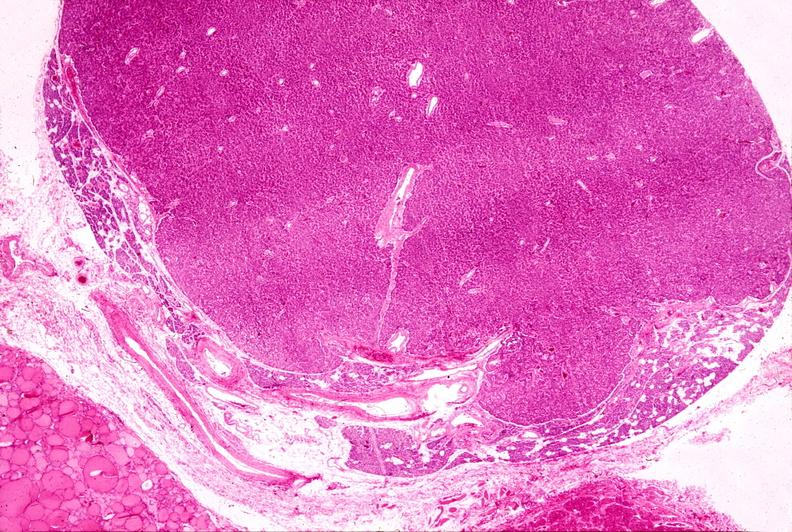where is this part in the figure?
Answer the question using a single word or phrase. Endocrine system 